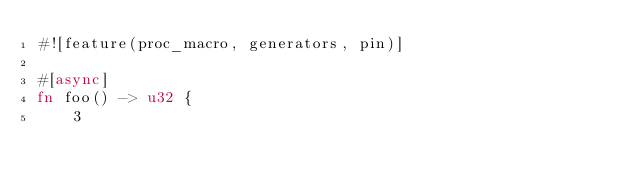<code> <loc_0><loc_0><loc_500><loc_500><_Rust_>#![feature(proc_macro, generators, pin)]

#[async]
fn foo() -> u32 {
    3</code> 